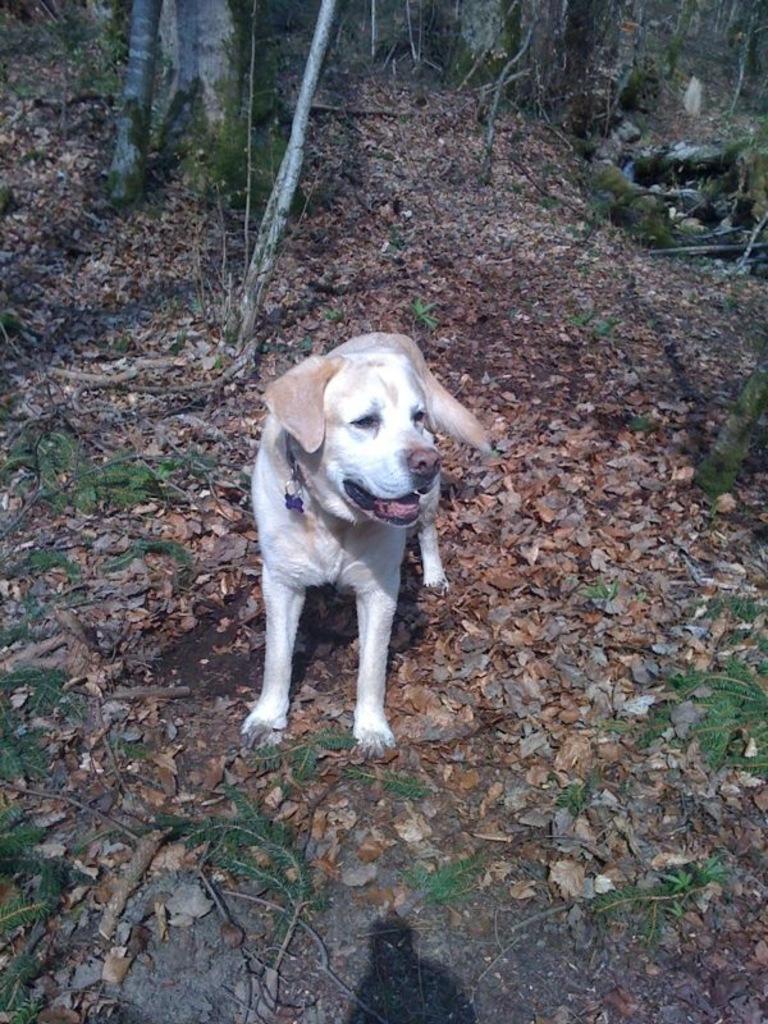Please provide a concise description of this image. In this image in the center there is one dog, and in a background there are some trees. At the bottom there are some dry leaves and some plants. 